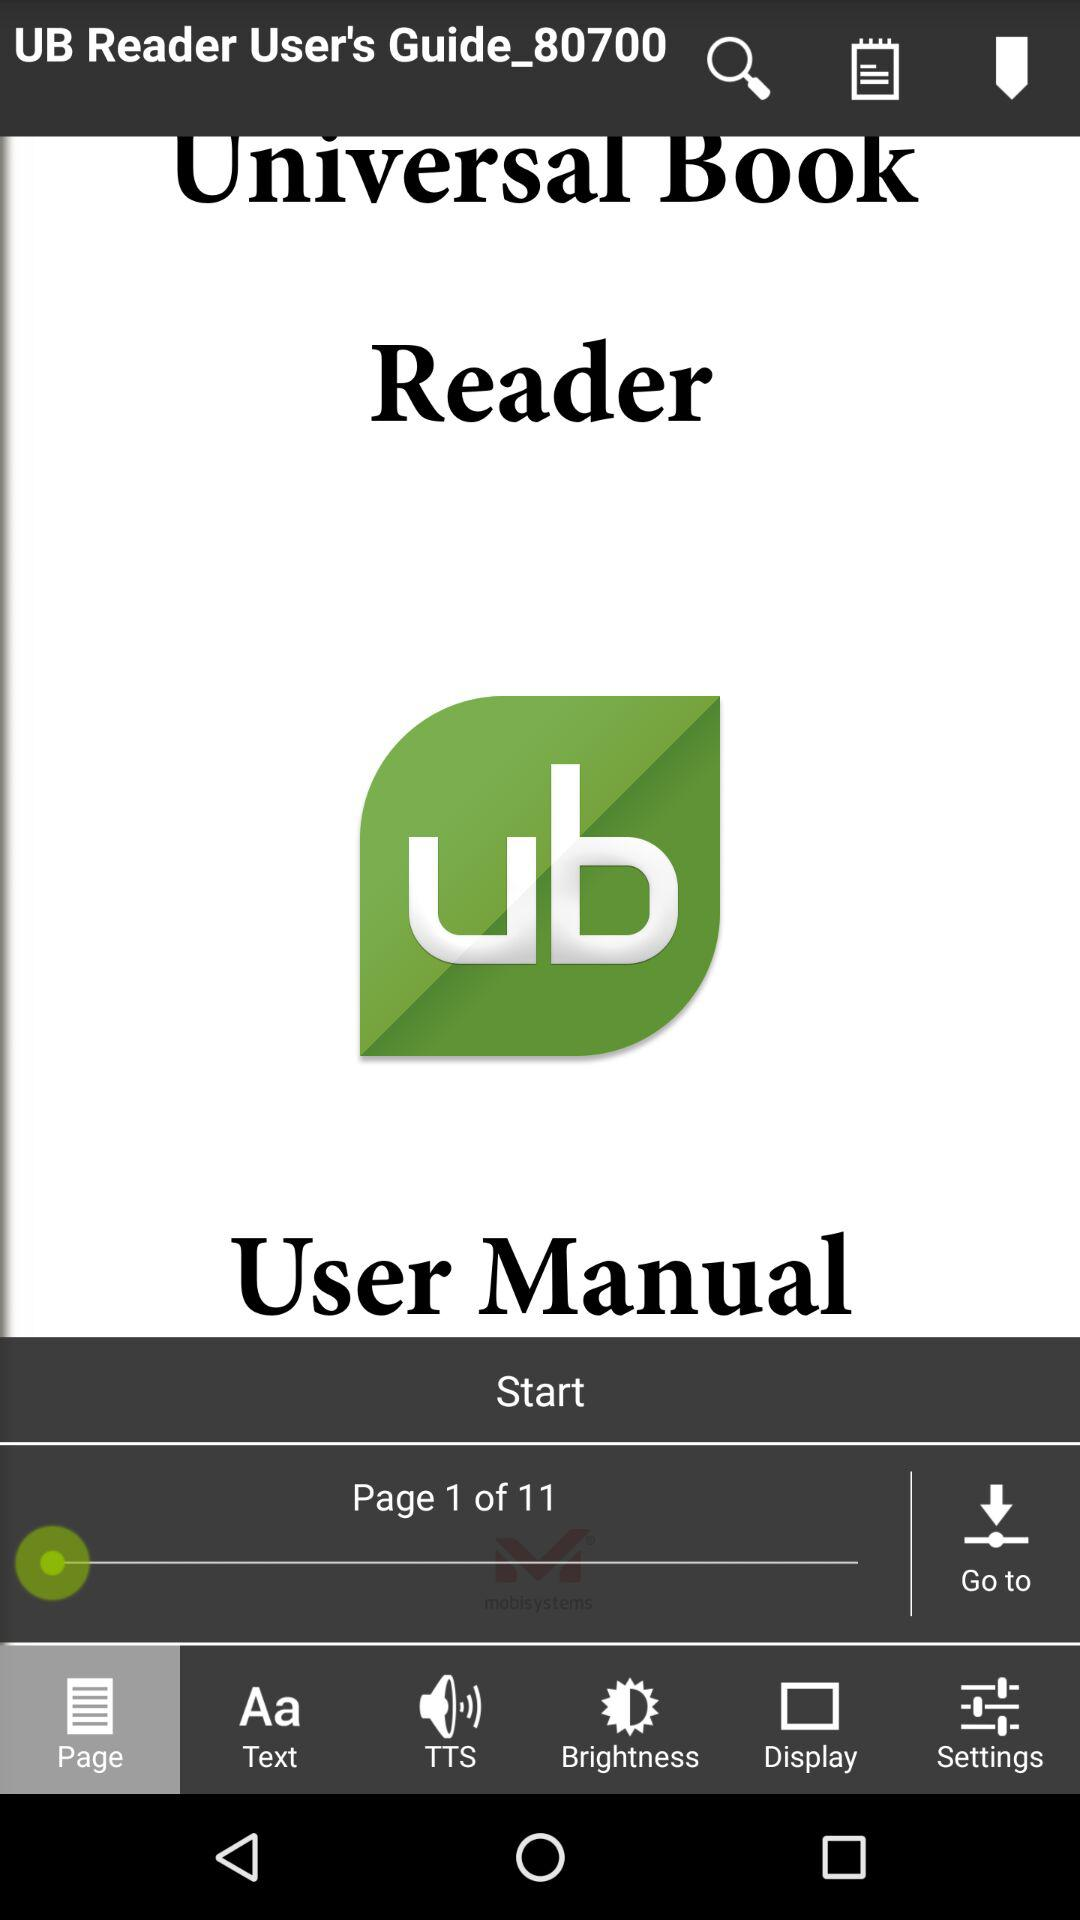How many notifications are there in "Text"?
When the provided information is insufficient, respond with <no answer>. <no answer> 